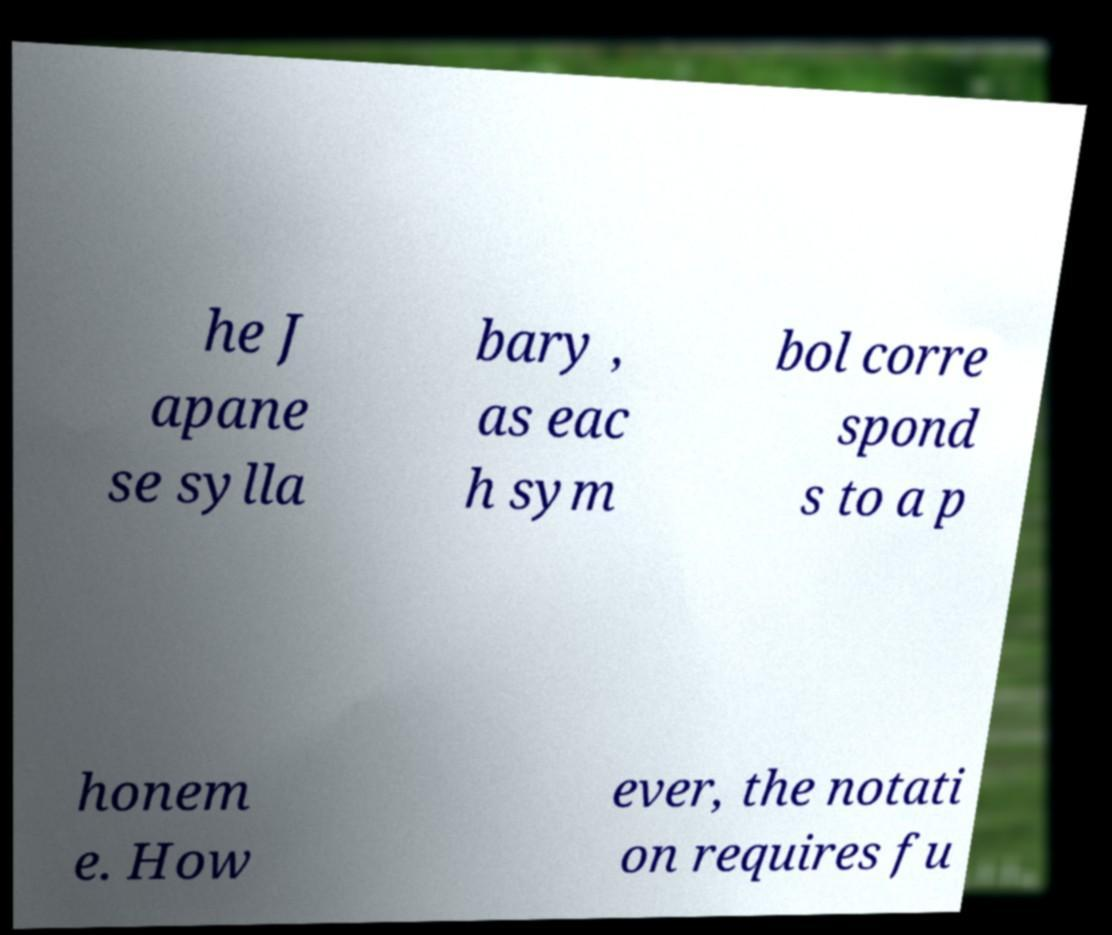Could you assist in decoding the text presented in this image and type it out clearly? he J apane se sylla bary , as eac h sym bol corre spond s to a p honem e. How ever, the notati on requires fu 